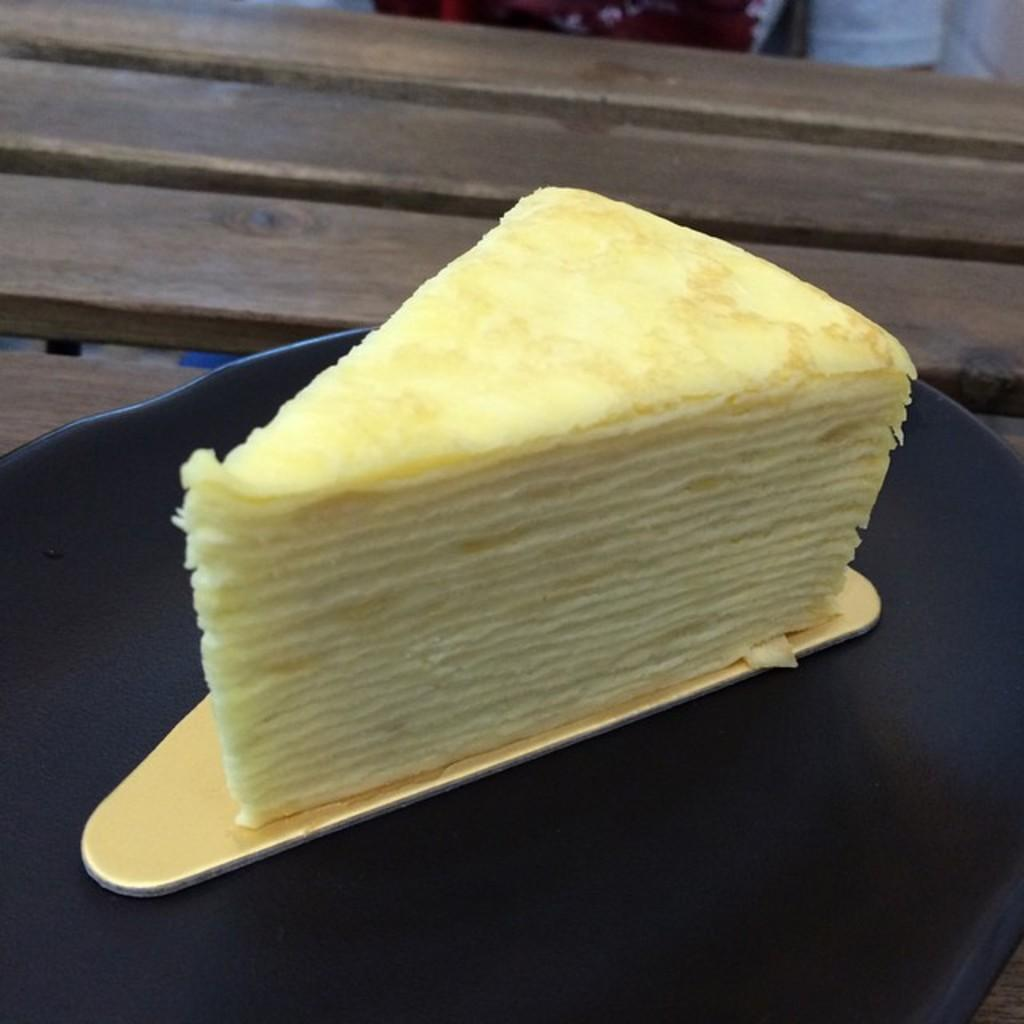What type of dessert is on the plate in the image? There is a cheesecake on a plate in the image. What is the plate resting on? The plate is on a wooden table. What type of fruit is being played on the guitar in the image? There is no guitar or fruit present in the image; it only features a cheesecake on a plate and a wooden table. 